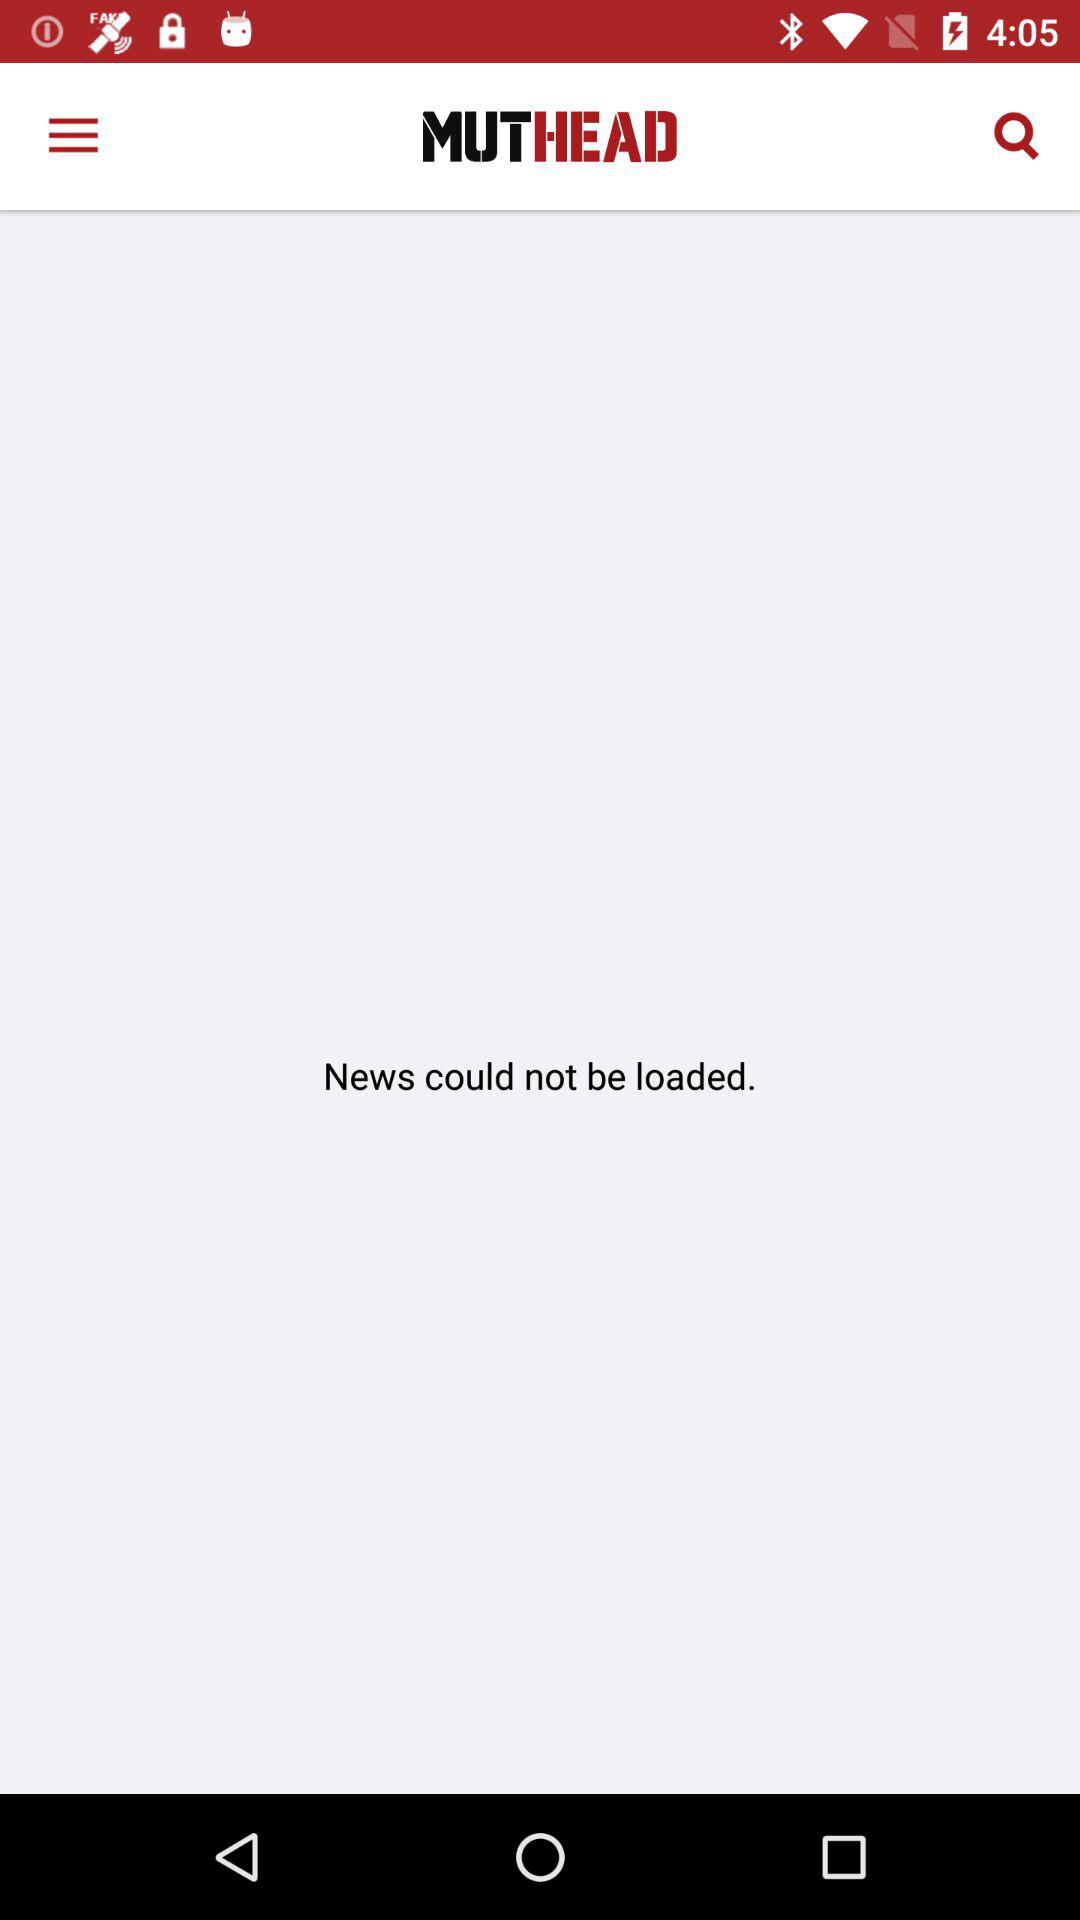What is the name of the application? The name of the application is "MUTHEAD". 